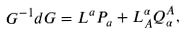Convert formula to latex. <formula><loc_0><loc_0><loc_500><loc_500>G ^ { - 1 } d G = L ^ { a } P _ { a } + L ^ { \alpha } _ { A } Q ^ { A } _ { \alpha } ,</formula> 